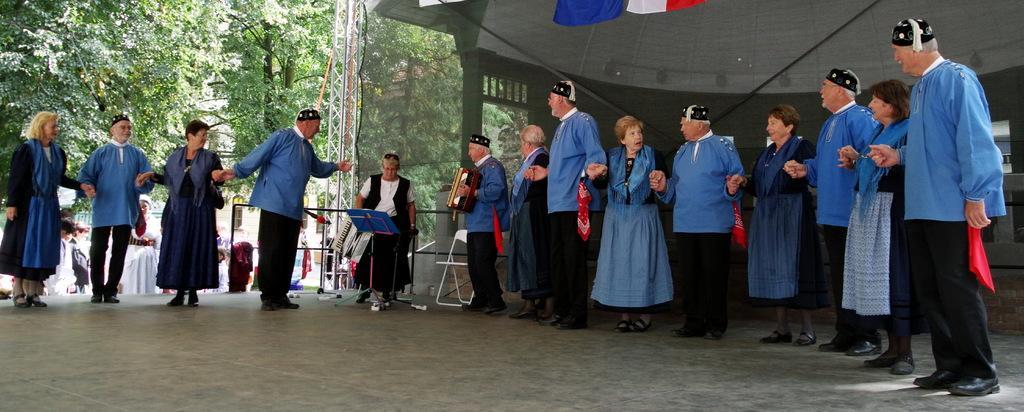How would you summarize this image in a sentence or two? In the center of the picture there are people standing and dancing. In the center of the picture there are two people playing harmonium. In the background to the left there are trees and people and a building. On the right there is a tent. 